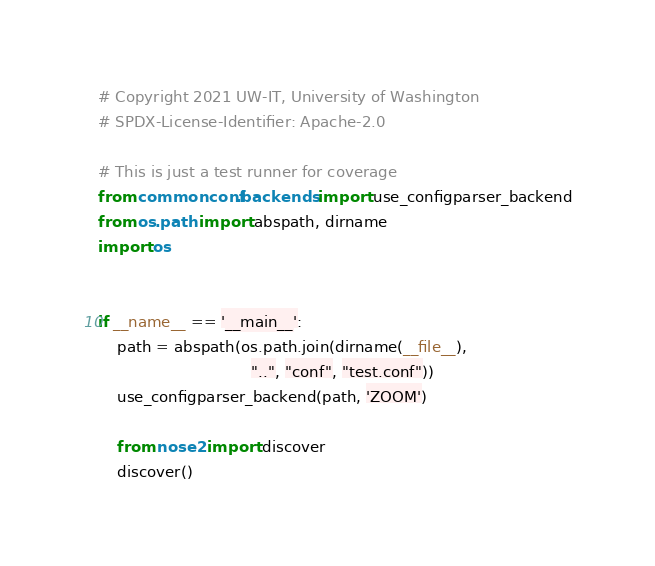<code> <loc_0><loc_0><loc_500><loc_500><_Python_># Copyright 2021 UW-IT, University of Washington
# SPDX-License-Identifier: Apache-2.0

# This is just a test runner for coverage
from commonconf.backends import use_configparser_backend
from os.path import abspath, dirname
import os


if __name__ == '__main__':
    path = abspath(os.path.join(dirname(__file__),
                                "..", "conf", "test.conf"))
    use_configparser_backend(path, 'ZOOM')

    from nose2 import discover
    discover()
</code> 